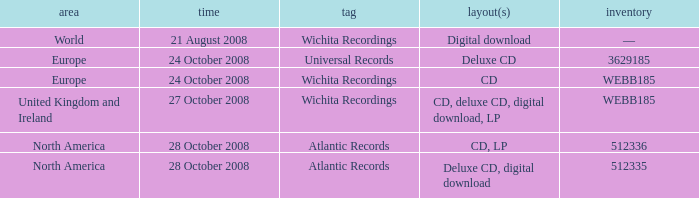Which formats have a region of Europe and Catalog value of WEBB185? CD. 